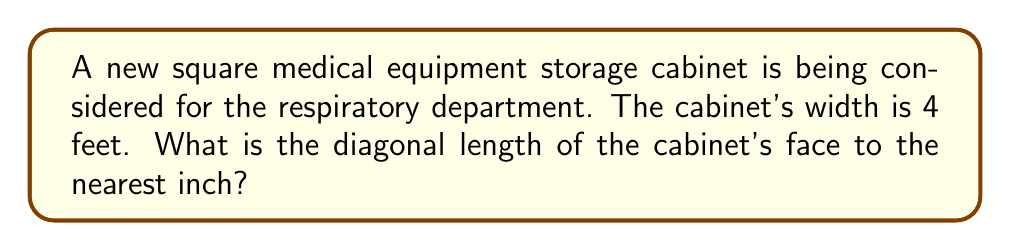Could you help me with this problem? Let's approach this step-by-step:

1) We know that the cabinet is square, so its width and height are equal (4 feet).

2) The diagonal of a square forms the hypotenuse of a right triangle, where the other two sides are the width and height of the square.

3) We can use the Pythagorean theorem to calculate the length of the diagonal. If we denote the diagonal as $d$, we have:

   $$d^2 = 4^2 + 4^2$$

4) Simplify:
   $$d^2 = 16 + 16 = 32$$

5) Take the square root of both sides:
   $$d = \sqrt{32}$$

6) Simplify the square root:
   $$d = 4\sqrt{2} \text{ feet}$$

7) To convert to inches, multiply by 12:
   $$d = 4\sqrt{2} \times 12 = 48\sqrt{2} \text{ inches}$$

8) Calculate the value:
   $$48\sqrt{2} \approx 67.88 \text{ inches}$$

9) Rounding to the nearest inch:
   $$68 \text{ inches}$$

[asy]
unitsize(20);
draw((0,0)--(4,0)--(4,4)--(0,4)--cycle);
draw((0,0)--(4,4),dashed);
label("4 ft", (2,0), S);
label("4 ft", (4,2), E);
label("d", (2,2), NW);
[/asy]
Answer: 68 inches 